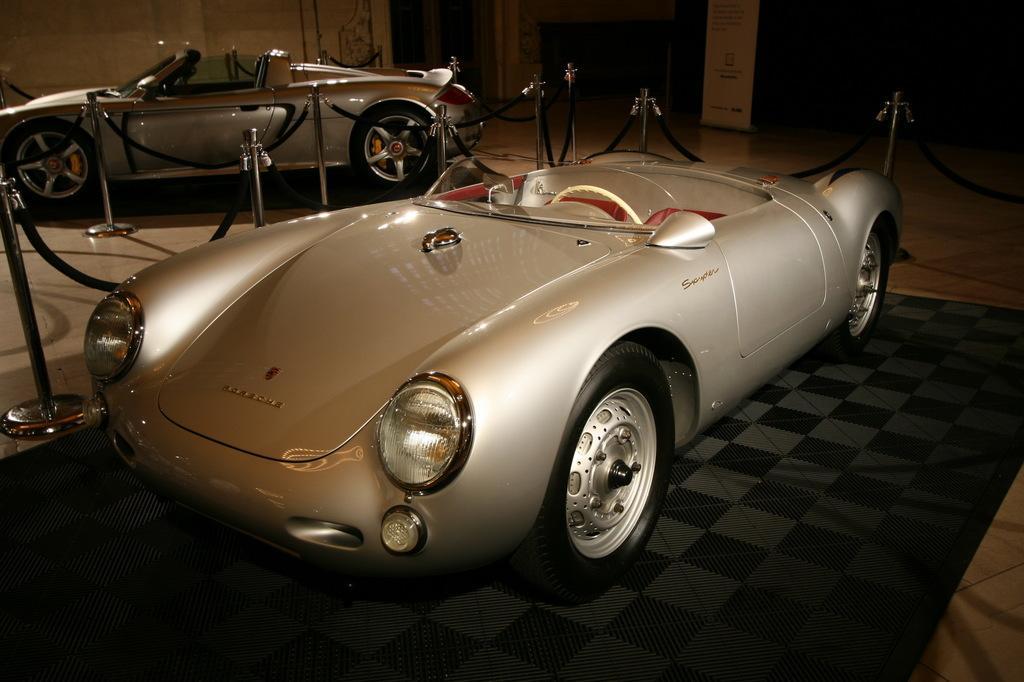Please provide a concise description of this image. In this image I can see two vehicles, they are in silver cover. I can also see few poles, and belts in black color and the floor is also in black color. Background I can see the wall in cream color. 